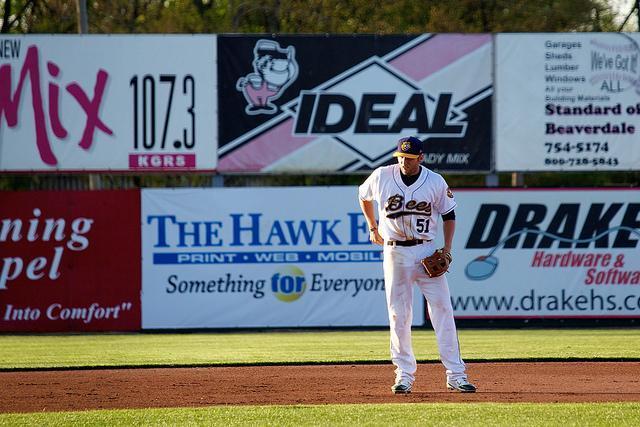How many people are there?
Give a very brief answer. 1. How many engines does the airplane have?
Give a very brief answer. 0. 